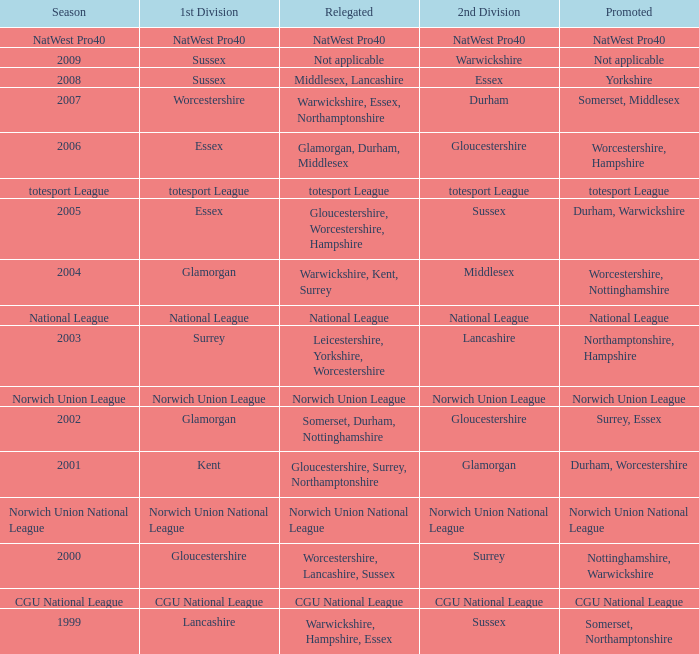What season was Norwich Union League promoted? Norwich Union League. 